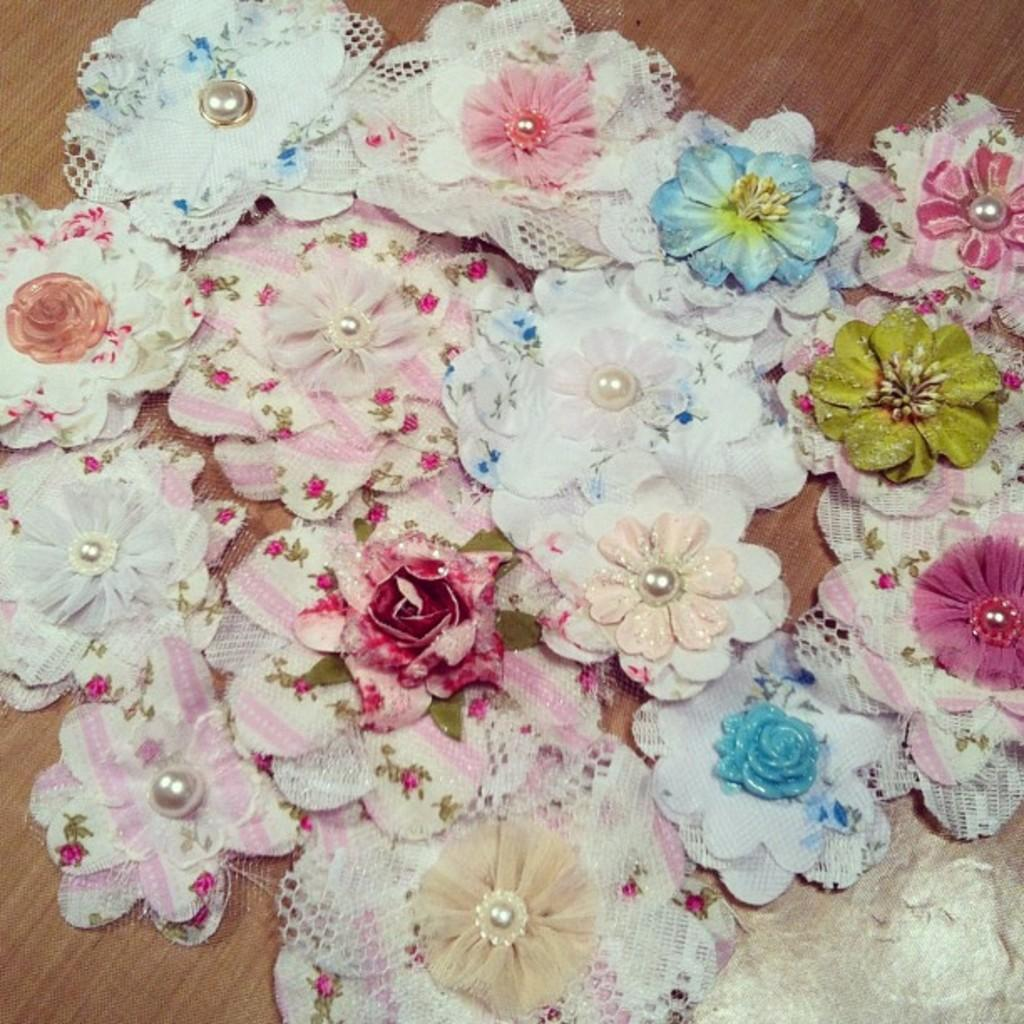What type of flowers are depicted in the image? The flowers in the image are made up of cloth. Where are the cloth flowers located? The cloth flowers are on a table. What material is the table made of? The table is made of wood. What type of cabbage is growing on the table in the image? There is no cabbage present in the image; the flowers are made of cloth. 